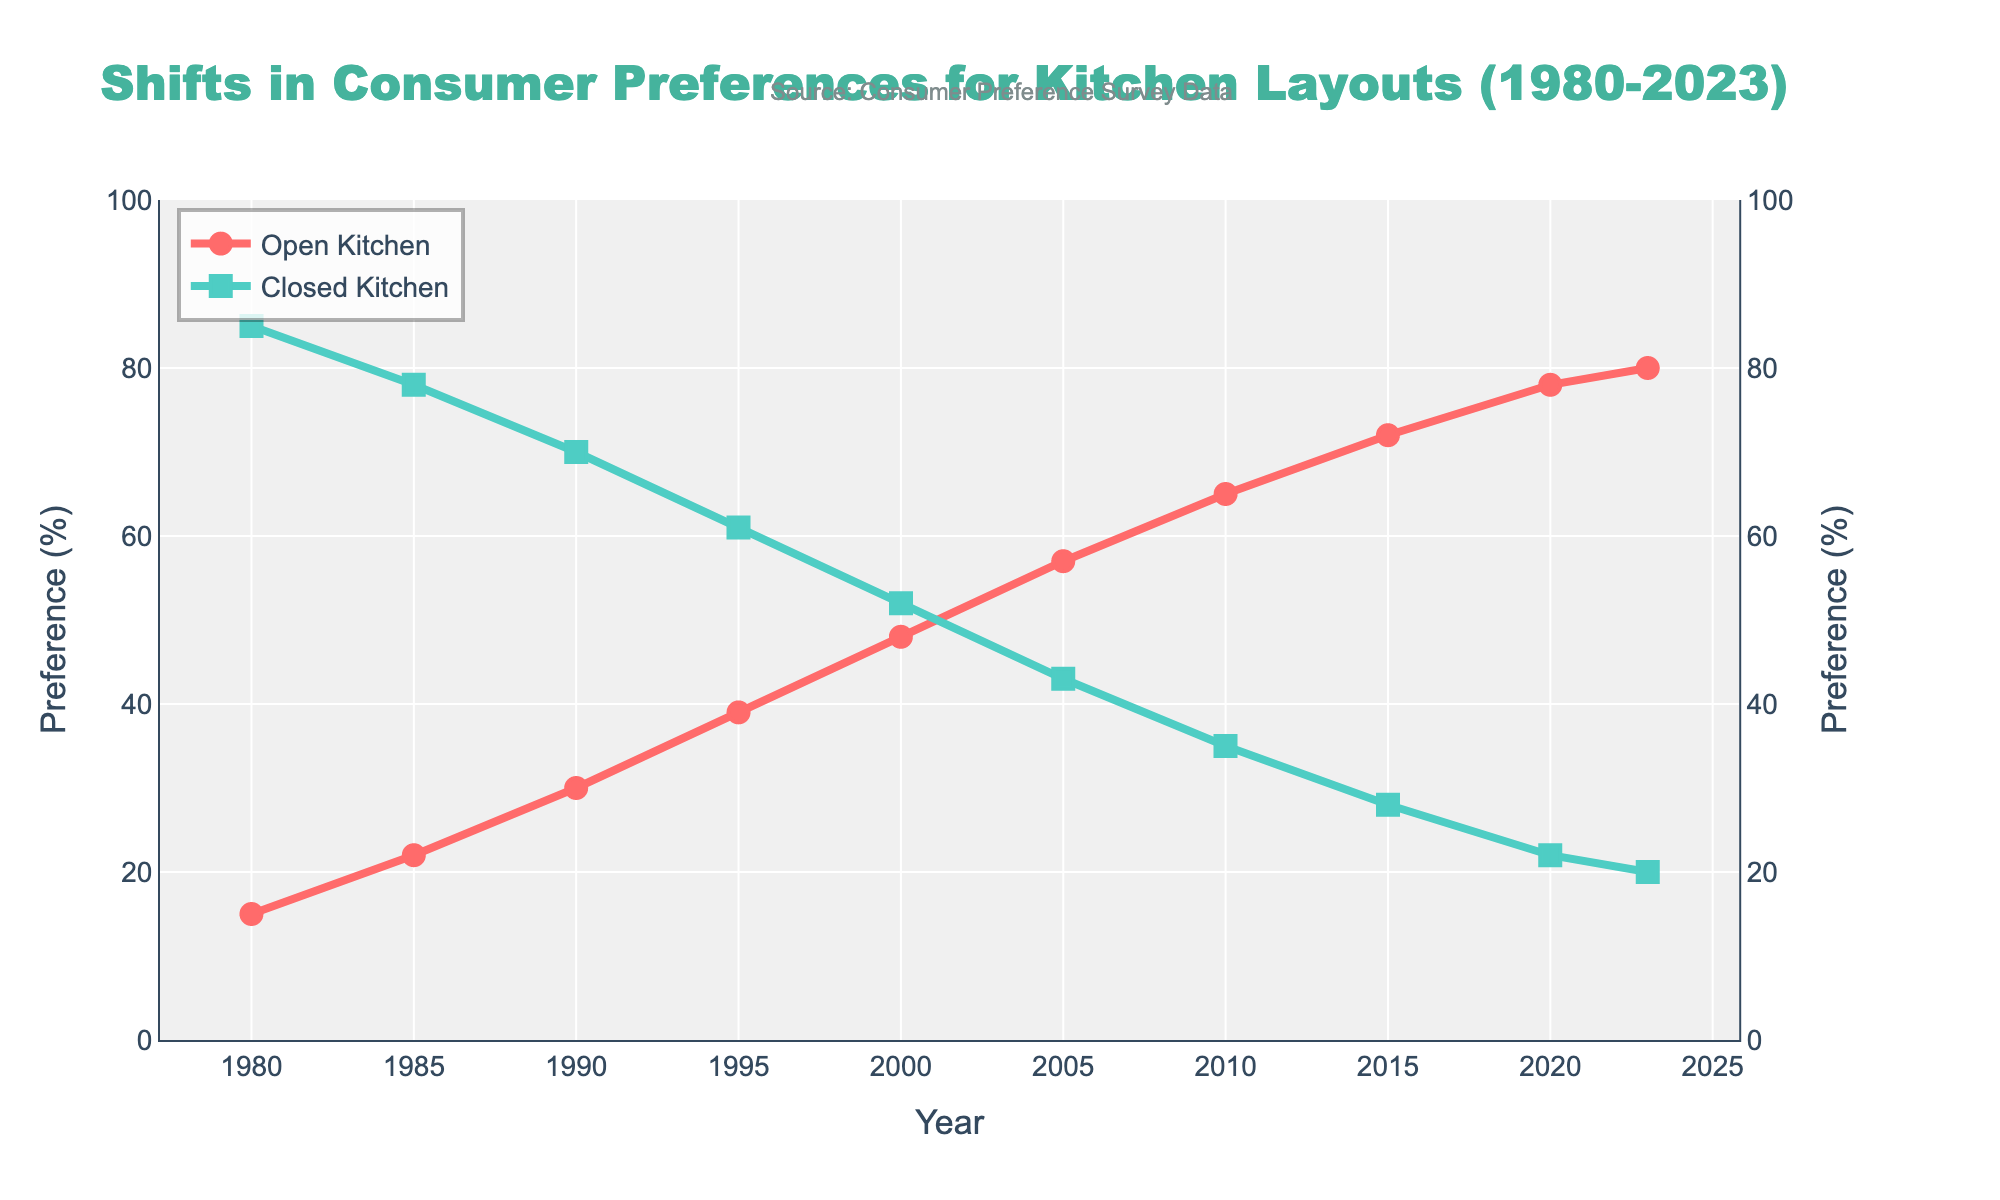What is the preference for open kitchens in 2023? The figure shows the "Open Kitchen Preference (%)" data for the year 2023. By examining the graph, we see the preference percentage marker for 2023.
Answer: 80% What is the trend between 1980 and 2023 for closed kitchen preferences? By looking at the line for "Closed Kitchen Preference (%)" from 1980 to 2023, we observe a downward trend. The preference starts high in 1980 and steadily decreases over the years.
Answer: Decreasing What is the difference in open kitchen preferences between 1990 and 2000? From the figure, identify the points for the years 1990 and 2000 under "Open Kitchen Preference (%)". In 1990, the preference is 30%, and in 2000, it’s 48%. Subtracting these values, 48% - 30% = 18%.
Answer: 18% In which year did open kitchen preferences surpass closed kitchen preferences? Find the point on the "Open Kitchen Preference (%)" and "Closed Kitchen Preference (%)" lines where the open kitchen line first goes above the closed kitchen line. It happens between 2000 and 2005, exactly in 2005.
Answer: 2005 How much did the closed kitchen preference decrease from 1985 to 2023? Identify the values for "Closed Kitchen Preference (%)" for 1985 and 2023. In 1985, it’s 78%, and in 2023, it’s 20%. The decrease is 78% - 20% = 58%.
Answer: 58% What is the combined percentage preference for both kitchen types in 2010? Check the preferences for open and closed kitchens in 2010 and add them together. Open kitchen is 65% and closed kitchen is 35%, 65% + 35% = 100%.
Answer: 100% Which kitchen layout had a higher preference in 1995? Compare the values of "Open Kitchen Preference (%)" and "Closed Kitchen Preference (%)" for the year 1995. Open kitchen preference is 39%, whereas closed kitchen preference is 61%.
Answer: Closed kitchen Is the preference for open kitchens above 50% in 2015? Look at the value for "Open Kitchen Preference (%)" in 2015. It is shown as 72%, which is above 50%.
Answer: Yes What is the average open kitchen preference between 1980 and 2023? Determine the average by summing the open kitchen preference percentages for all listed years and then divide by the number of years. The values are 15, 22, 30, 39, 48, 57, 65, 72, 78, 80, sum = 506. The average is 506 / 10 = 50.6%.
Answer: 50.6% Was there any year when the closed kitchen preference was exactly twice the open kitchen preference? Examine the data points for each year and check the ratio between "Closed Kitchen Preference (%)" and "Open Kitchen Preference (%)". In 1985, the preferences are 78% for closed and 22% for open, and 78% is slightly more than three times 22%, no other years match.
Answer: No 